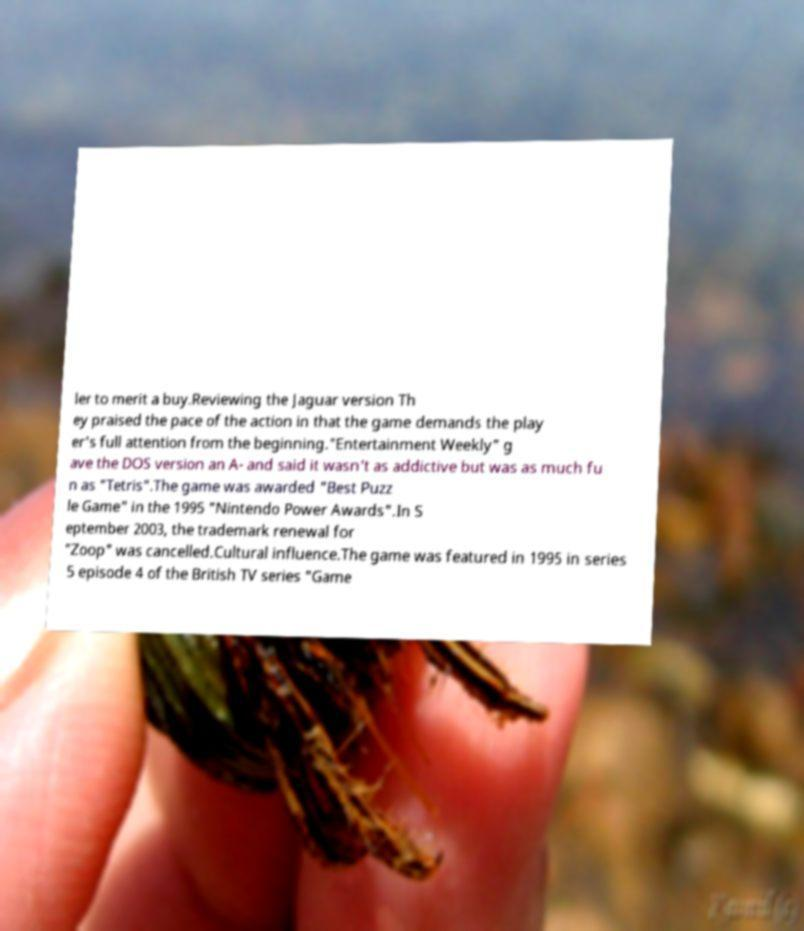Can you accurately transcribe the text from the provided image for me? ler to merit a buy.Reviewing the Jaguar version Th ey praised the pace of the action in that the game demands the play er's full attention from the beginning."Entertainment Weekly" g ave the DOS version an A- and said it wasn't as addictive but was as much fu n as "Tetris".The game was awarded "Best Puzz le Game" in the 1995 "Nintendo Power Awards".In S eptember 2003, the trademark renewal for "Zoop" was cancelled.Cultural influence.The game was featured in 1995 in series 5 episode 4 of the British TV series "Game 